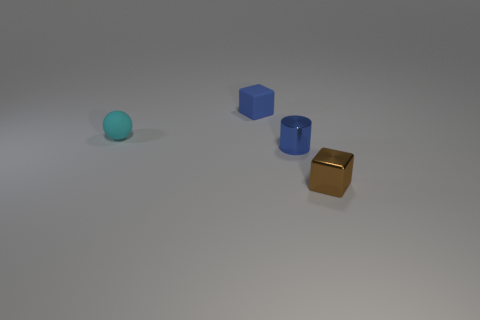Can you infer any specific use or function for these objects? Inferring from their simplicity and uniformity of material, these objects might be used as educational tools for teaching shapes and colors to children. They could also function as part of a sorting game or be decor elements in a minimalist space. 